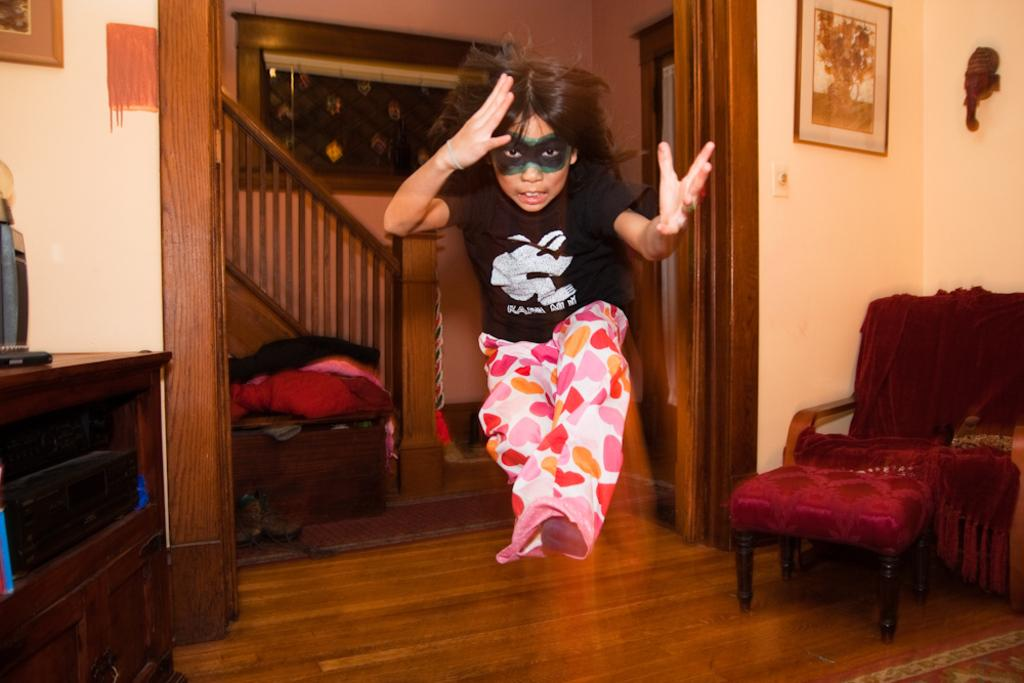Who is the main subject in the image? There is a girl in the image. What is the girl doing in the image? The girl is jumping in a living room. What objects can be seen in the background of the image? There is a cupboard, a frame, an idol, a chair, a staircase, a ribbon, a blanket, and shoes in the background of the image. What type of pizzas are being served in the image? There are no pizzas present in the image. What is the purpose of the girl jumping in the image? The image does not provide information about the purpose of the girl's action. 